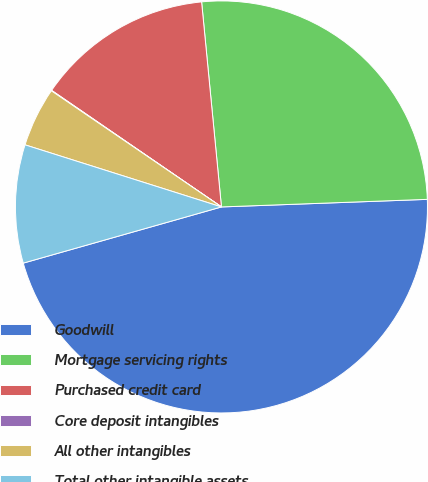Convert chart to OTSL. <chart><loc_0><loc_0><loc_500><loc_500><pie_chart><fcel>Goodwill<fcel>Mortgage servicing rights<fcel>Purchased credit card<fcel>Core deposit intangibles<fcel>All other intangibles<fcel>Total other intangible assets<nl><fcel>46.19%<fcel>25.95%<fcel>13.89%<fcel>0.04%<fcel>4.66%<fcel>9.27%<nl></chart> 